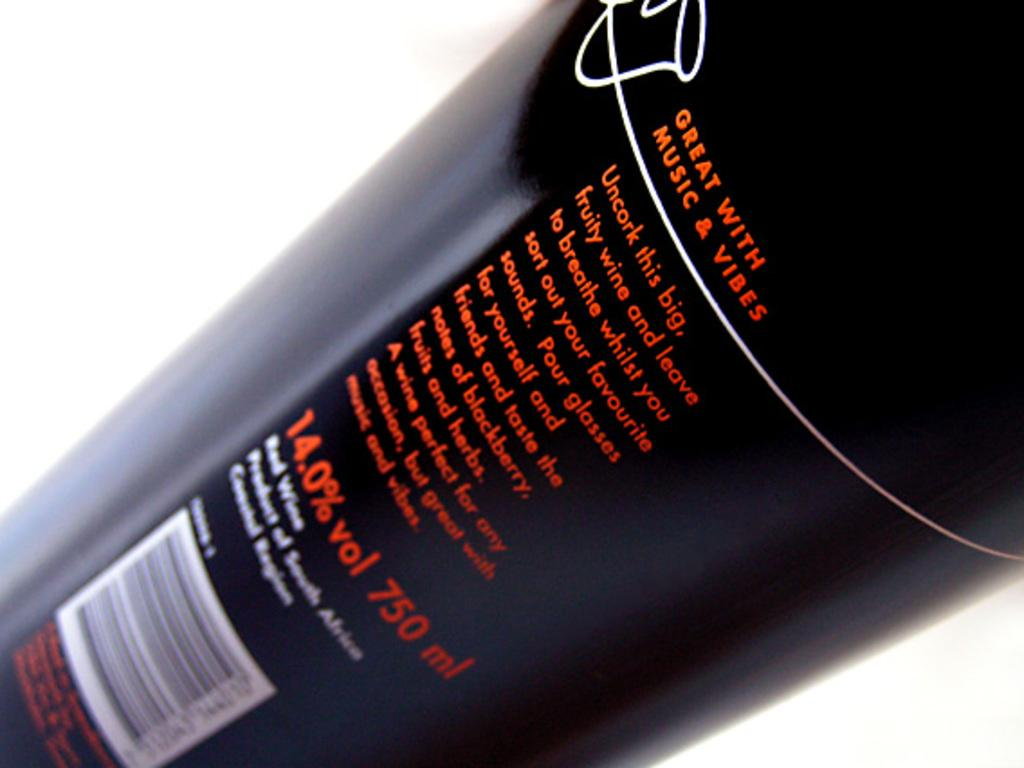<image>
Offer a succinct explanation of the picture presented. Black bottle of alcholo display great with music and vibes. 